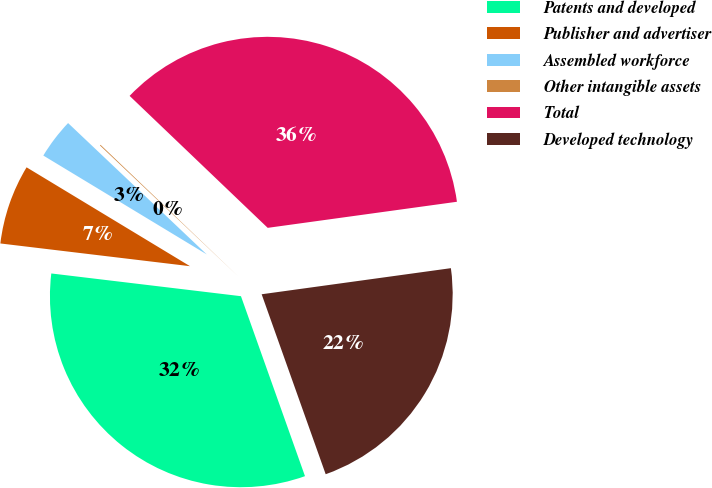<chart> <loc_0><loc_0><loc_500><loc_500><pie_chart><fcel>Patents and developed<fcel>Publisher and advertiser<fcel>Assembled workforce<fcel>Other intangible assets<fcel>Total<fcel>Developed technology<nl><fcel>32.34%<fcel>6.76%<fcel>3.41%<fcel>0.07%<fcel>35.68%<fcel>21.74%<nl></chart> 